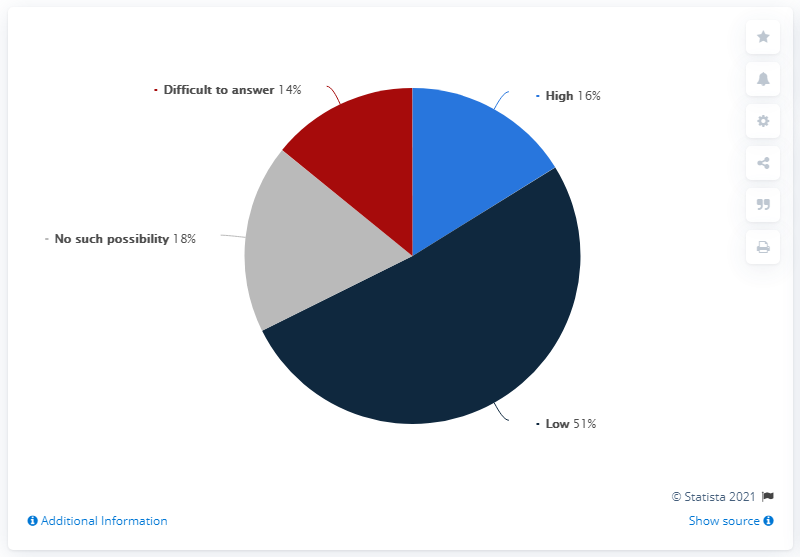Draw attention to some important aspects in this diagram. There is no possibility that there is no possibility. The probability that the corona virus is high is 16%. 